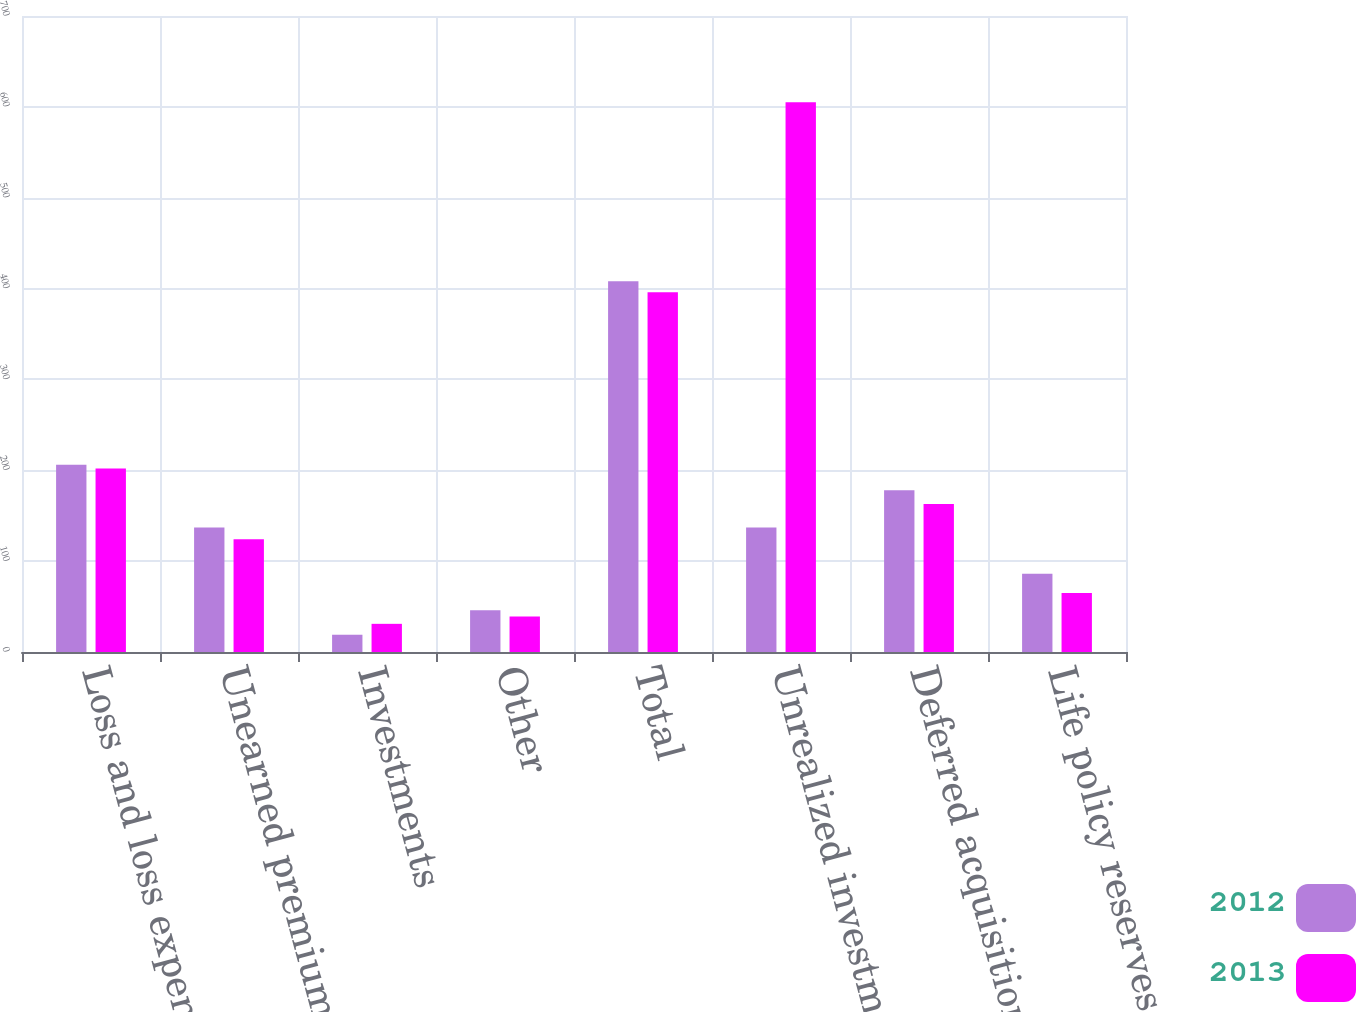<chart> <loc_0><loc_0><loc_500><loc_500><stacked_bar_chart><ecel><fcel>Loss and loss expense reserves<fcel>Unearned premiums<fcel>Investments<fcel>Other<fcel>Total<fcel>Unrealized investment gains<fcel>Deferred acquisition costs<fcel>Life policy reserves<nl><fcel>2012<fcel>206<fcel>137<fcel>19<fcel>46<fcel>408<fcel>137<fcel>178<fcel>86<nl><fcel>2013<fcel>202<fcel>124<fcel>31<fcel>39<fcel>396<fcel>605<fcel>163<fcel>65<nl></chart> 